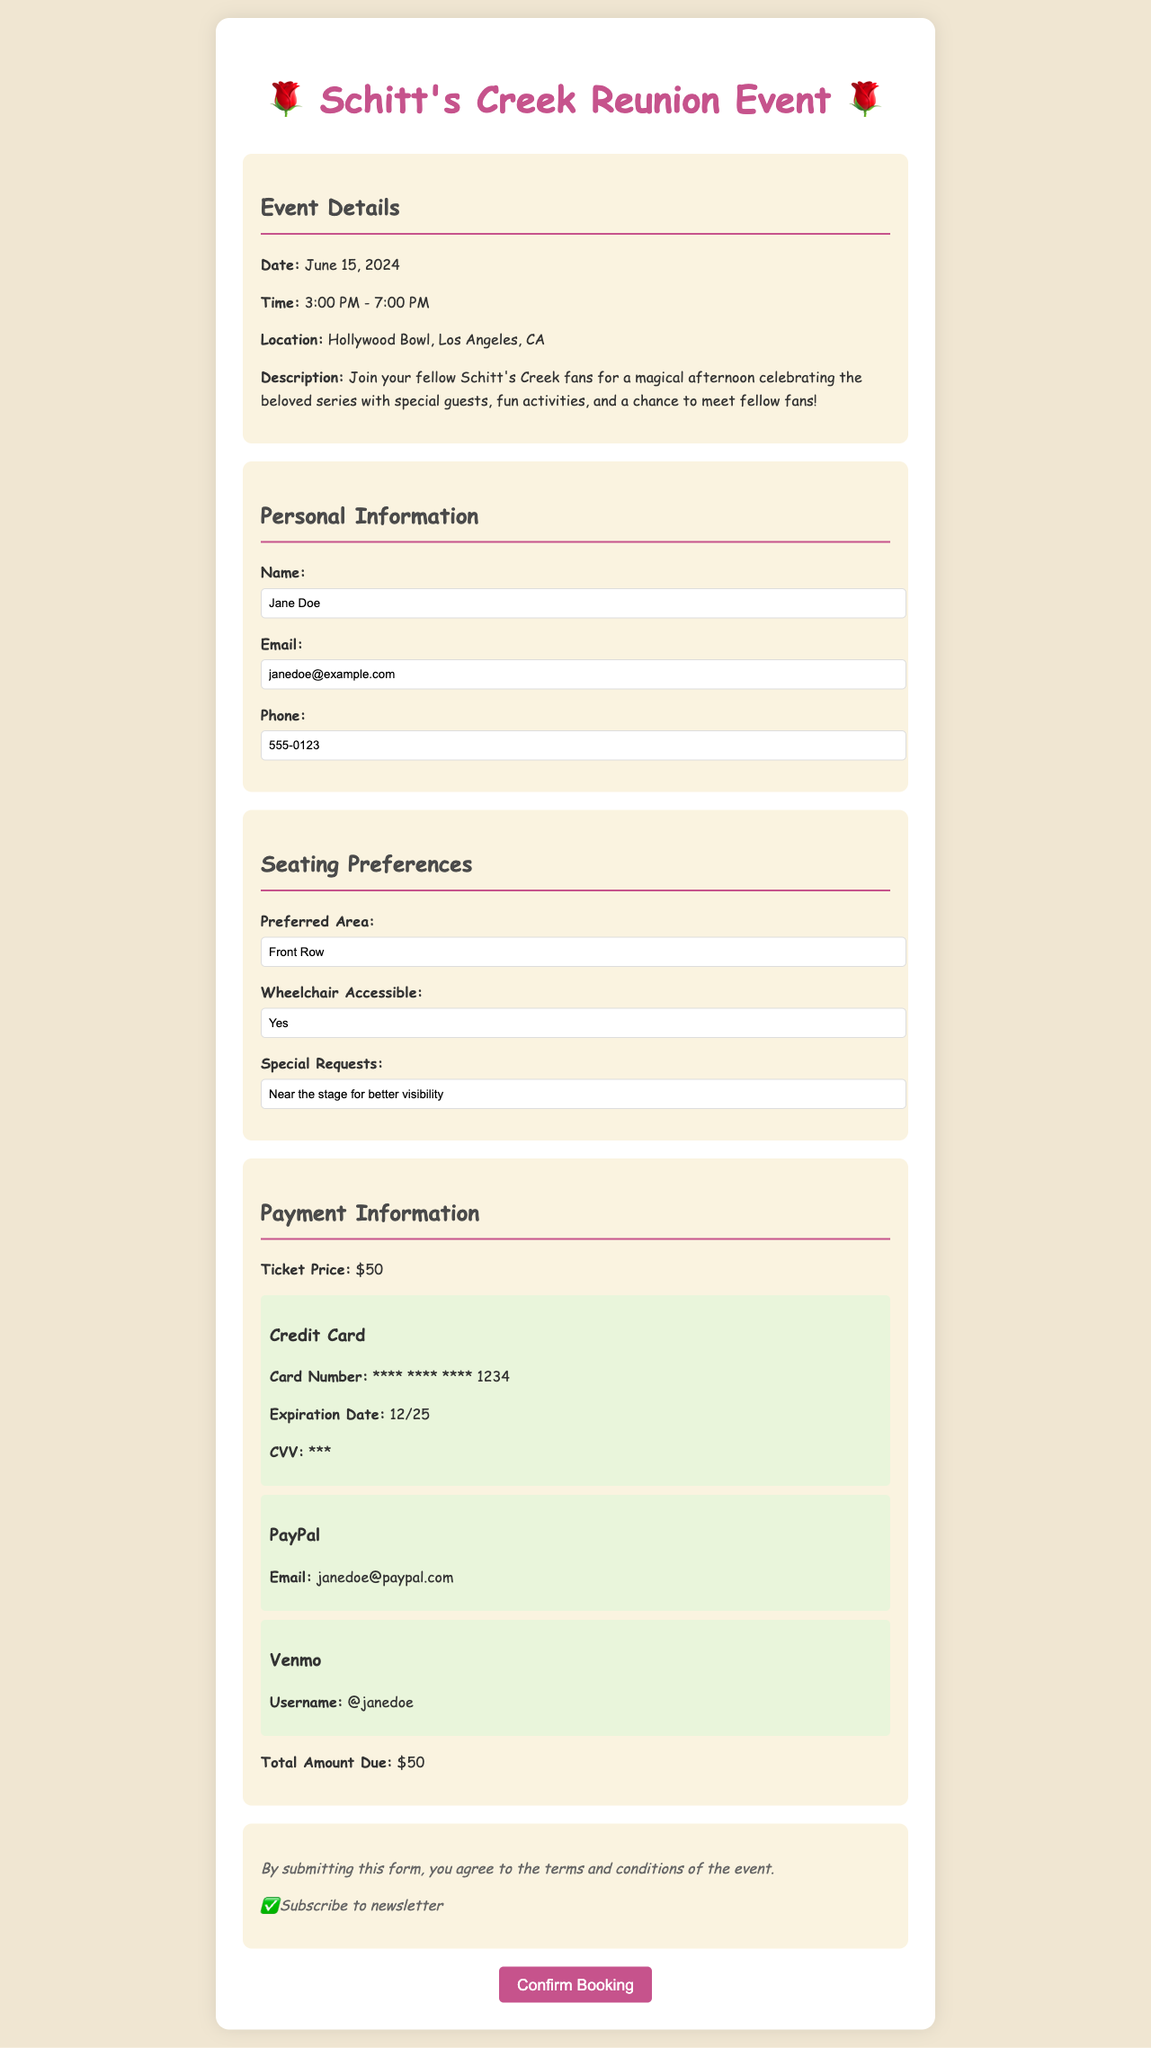What is the date of the event? The date of the event is stated in the "Event Details" section of the document.
Answer: June 15, 2024 What is the location of the event? The location can be found in the "Event Details" section of the document.
Answer: Hollywood Bowl, Los Angeles, CA How much is the ticket price? The ticket price is clearly mentioned in the "Payment Information" section of the document.
Answer: $50 What is the preferred seating area? The preferred seating area is listed in the "Seating Preferences" section of the form.
Answer: Front Row Is there a wheelchair accessible option? This information is provided under the "Seating Preferences" section.
Answer: Yes What special request did the attendee make? The special request can be found in the "Seating Preferences" section.
Answer: Near the stage for better visibility What payment methods are available? The various payment options are detailed in the "Payment Information" section.
Answer: Credit Card, PayPal, Venmo What is the total amount due? The total amount due is stated towards the end of the "Payment Information" section.
Answer: $50 What time does the event start? The start time is outlined in the "Event Details" section of the document.
Answer: 3:00 PM 